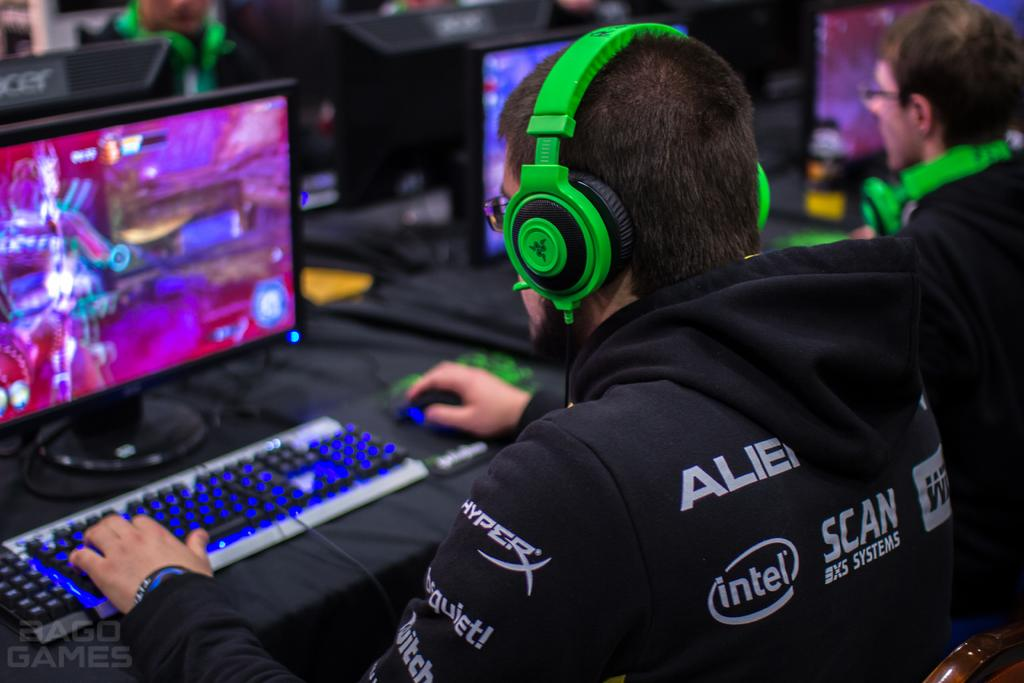<image>
Relay a brief, clear account of the picture shown. A man wearing bright green headphones has many sponsors on his hoodie, including intel. 